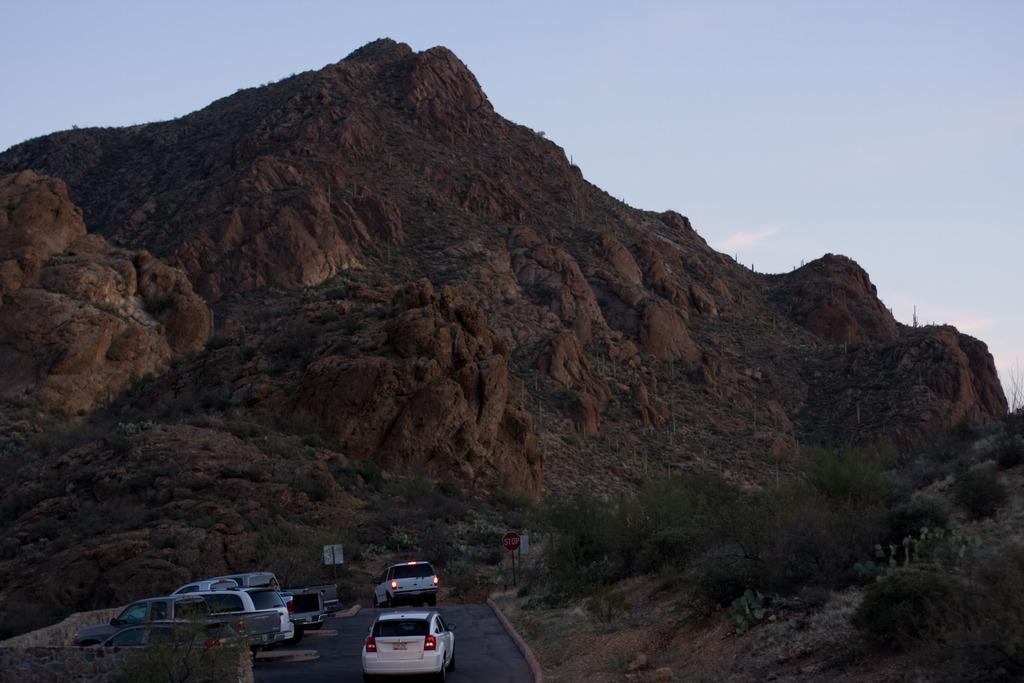What can be seen on the road in the image? There are vehicles on the road in the image. What type of natural elements are present in the image? There are plants and a mountain in the image. What structures can be seen in the image? There are poles, boards, and a wall in the image. What is visible in the background of the image? The sky is visible in the background of the image. What type of ink is being used to write on the mountain in the image? There is no ink or writing present on the mountain in the image. What tool is being used to fix the wrench on the wall in the image? There is no wrench or tool present on the wall in the image. 